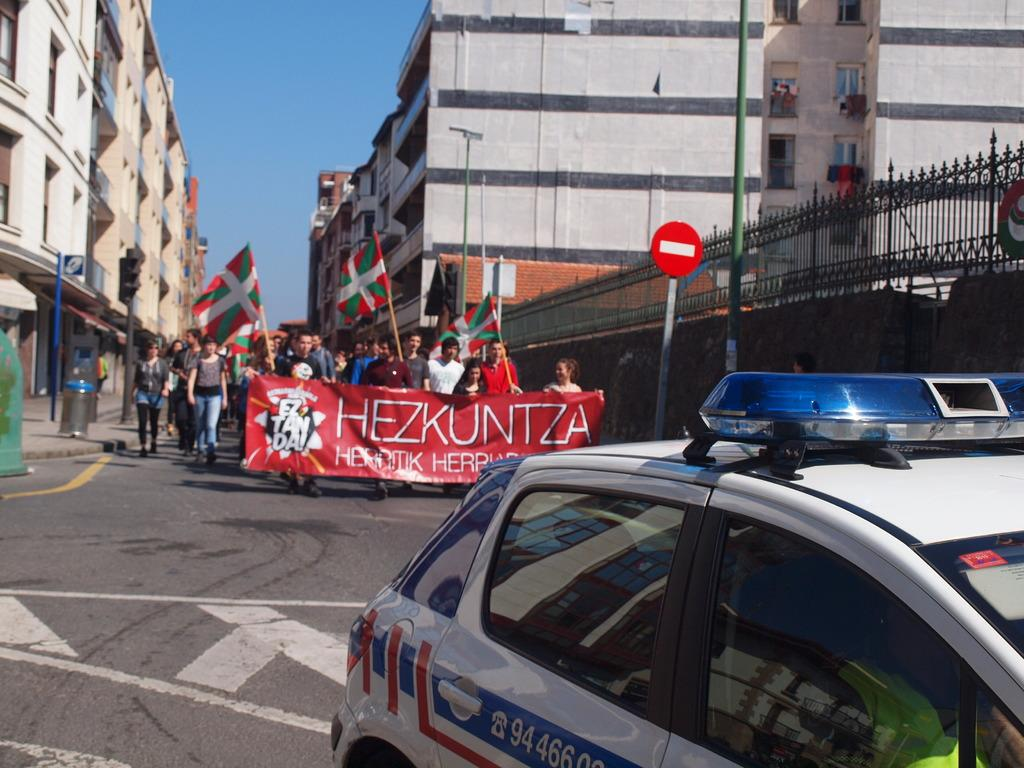What is the main subject of the image? There is a vehicle on the road in the image. What are the people in the image doing? The people are holding flags in the image. What can be seen in the background of the image? There are buildings and the sky visible in the background of the image. What is the historical significance of the vehicle in the image? There is no information provided about the historical significance of the vehicle in the image. How does the person holding the flag maintain their grip on the flagpole? The image does not provide information about how the person is gripping the flagpole. 